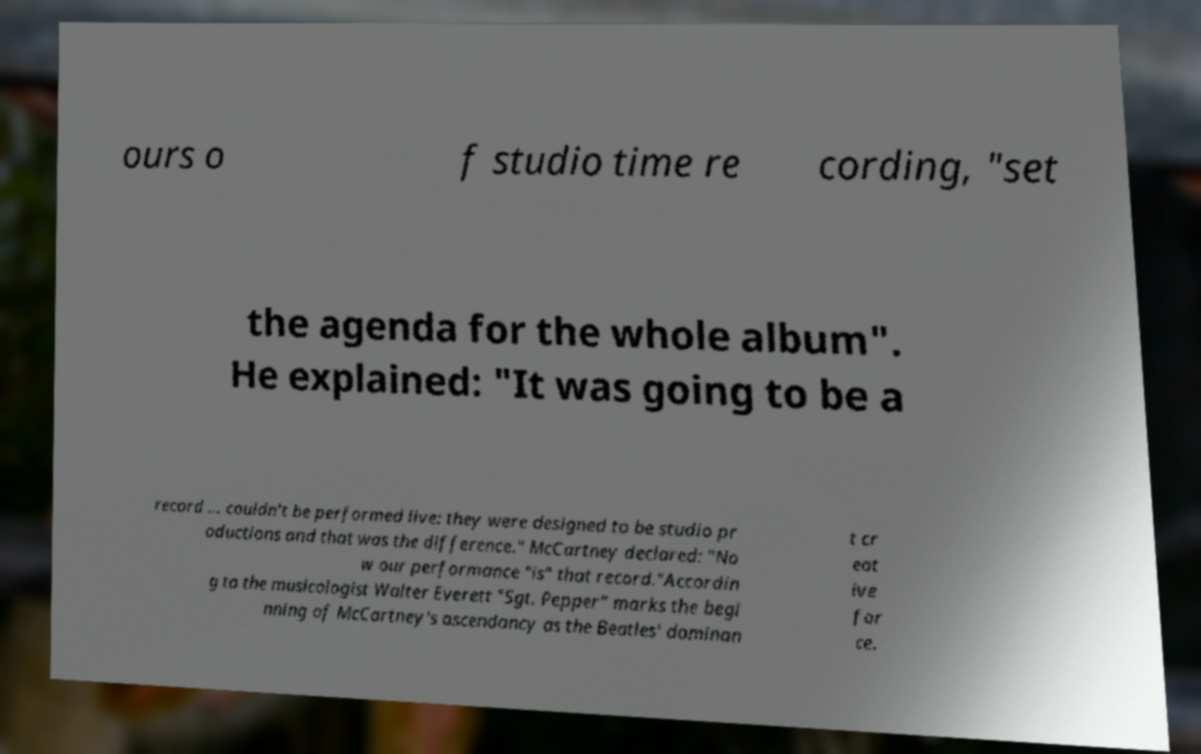Please read and relay the text visible in this image. What does it say? ours o f studio time re cording, "set the agenda for the whole album". He explained: "It was going to be a record ... couldn't be performed live: they were designed to be studio pr oductions and that was the difference." McCartney declared: "No w our performance "is" that record."Accordin g to the musicologist Walter Everett "Sgt. Pepper" marks the begi nning of McCartney's ascendancy as the Beatles' dominan t cr eat ive for ce. 